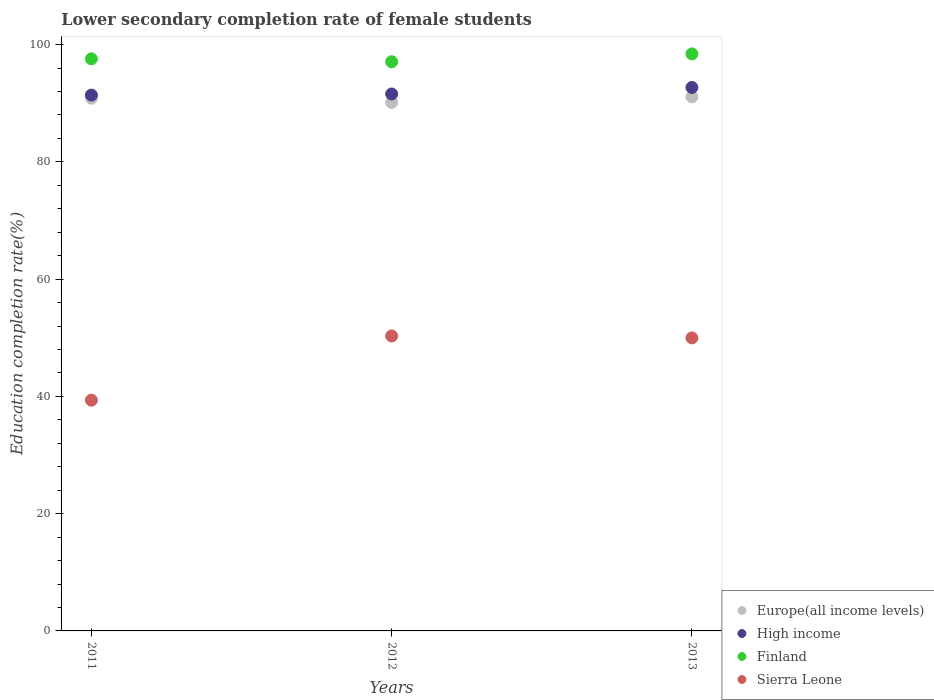What is the lower secondary completion rate of female students in Europe(all income levels) in 2012?
Give a very brief answer. 90.13. Across all years, what is the maximum lower secondary completion rate of female students in Sierra Leone?
Provide a short and direct response. 50.3. Across all years, what is the minimum lower secondary completion rate of female students in Europe(all income levels)?
Offer a very short reply. 90.13. What is the total lower secondary completion rate of female students in Finland in the graph?
Keep it short and to the point. 293.03. What is the difference between the lower secondary completion rate of female students in Europe(all income levels) in 2011 and that in 2012?
Keep it short and to the point. 0.72. What is the difference between the lower secondary completion rate of female students in Europe(all income levels) in 2011 and the lower secondary completion rate of female students in Finland in 2013?
Make the answer very short. -7.56. What is the average lower secondary completion rate of female students in Sierra Leone per year?
Your answer should be very brief. 46.54. In the year 2012, what is the difference between the lower secondary completion rate of female students in Europe(all income levels) and lower secondary completion rate of female students in High income?
Your response must be concise. -1.45. What is the ratio of the lower secondary completion rate of female students in Europe(all income levels) in 2012 to that in 2013?
Make the answer very short. 0.99. What is the difference between the highest and the second highest lower secondary completion rate of female students in Sierra Leone?
Offer a terse response. 0.33. What is the difference between the highest and the lowest lower secondary completion rate of female students in Sierra Leone?
Ensure brevity in your answer.  10.95. Is it the case that in every year, the sum of the lower secondary completion rate of female students in High income and lower secondary completion rate of female students in Sierra Leone  is greater than the sum of lower secondary completion rate of female students in Europe(all income levels) and lower secondary completion rate of female students in Finland?
Give a very brief answer. No. Is it the case that in every year, the sum of the lower secondary completion rate of female students in Europe(all income levels) and lower secondary completion rate of female students in Finland  is greater than the lower secondary completion rate of female students in Sierra Leone?
Your answer should be compact. Yes. Is the lower secondary completion rate of female students in Sierra Leone strictly less than the lower secondary completion rate of female students in High income over the years?
Ensure brevity in your answer.  Yes. How many dotlines are there?
Keep it short and to the point. 4. What is the difference between two consecutive major ticks on the Y-axis?
Your answer should be compact. 20. Are the values on the major ticks of Y-axis written in scientific E-notation?
Give a very brief answer. No. Does the graph contain any zero values?
Keep it short and to the point. No. Does the graph contain grids?
Make the answer very short. No. Where does the legend appear in the graph?
Your answer should be very brief. Bottom right. What is the title of the graph?
Keep it short and to the point. Lower secondary completion rate of female students. Does "Kenya" appear as one of the legend labels in the graph?
Ensure brevity in your answer.  No. What is the label or title of the Y-axis?
Your response must be concise. Education completion rate(%). What is the Education completion rate(%) of Europe(all income levels) in 2011?
Your response must be concise. 90.84. What is the Education completion rate(%) in High income in 2011?
Make the answer very short. 91.38. What is the Education completion rate(%) of Finland in 2011?
Provide a short and direct response. 97.56. What is the Education completion rate(%) of Sierra Leone in 2011?
Offer a terse response. 39.35. What is the Education completion rate(%) of Europe(all income levels) in 2012?
Provide a succinct answer. 90.13. What is the Education completion rate(%) in High income in 2012?
Give a very brief answer. 91.57. What is the Education completion rate(%) of Finland in 2012?
Your response must be concise. 97.06. What is the Education completion rate(%) of Sierra Leone in 2012?
Provide a short and direct response. 50.3. What is the Education completion rate(%) of Europe(all income levels) in 2013?
Keep it short and to the point. 91.08. What is the Education completion rate(%) of High income in 2013?
Provide a short and direct response. 92.68. What is the Education completion rate(%) of Finland in 2013?
Make the answer very short. 98.41. What is the Education completion rate(%) of Sierra Leone in 2013?
Provide a short and direct response. 49.97. Across all years, what is the maximum Education completion rate(%) in Europe(all income levels)?
Provide a succinct answer. 91.08. Across all years, what is the maximum Education completion rate(%) of High income?
Give a very brief answer. 92.68. Across all years, what is the maximum Education completion rate(%) of Finland?
Keep it short and to the point. 98.41. Across all years, what is the maximum Education completion rate(%) of Sierra Leone?
Ensure brevity in your answer.  50.3. Across all years, what is the minimum Education completion rate(%) in Europe(all income levels)?
Ensure brevity in your answer.  90.13. Across all years, what is the minimum Education completion rate(%) in High income?
Provide a succinct answer. 91.38. Across all years, what is the minimum Education completion rate(%) in Finland?
Your response must be concise. 97.06. Across all years, what is the minimum Education completion rate(%) in Sierra Leone?
Your answer should be very brief. 39.35. What is the total Education completion rate(%) of Europe(all income levels) in the graph?
Your response must be concise. 272.05. What is the total Education completion rate(%) of High income in the graph?
Offer a very short reply. 275.63. What is the total Education completion rate(%) of Finland in the graph?
Provide a short and direct response. 293.03. What is the total Education completion rate(%) of Sierra Leone in the graph?
Make the answer very short. 139.63. What is the difference between the Education completion rate(%) of Europe(all income levels) in 2011 and that in 2012?
Your answer should be compact. 0.72. What is the difference between the Education completion rate(%) of High income in 2011 and that in 2012?
Your answer should be very brief. -0.19. What is the difference between the Education completion rate(%) of Finland in 2011 and that in 2012?
Your answer should be compact. 0.5. What is the difference between the Education completion rate(%) in Sierra Leone in 2011 and that in 2012?
Your answer should be compact. -10.95. What is the difference between the Education completion rate(%) in Europe(all income levels) in 2011 and that in 2013?
Give a very brief answer. -0.24. What is the difference between the Education completion rate(%) in High income in 2011 and that in 2013?
Provide a succinct answer. -1.3. What is the difference between the Education completion rate(%) of Finland in 2011 and that in 2013?
Your answer should be very brief. -0.84. What is the difference between the Education completion rate(%) in Sierra Leone in 2011 and that in 2013?
Provide a short and direct response. -10.62. What is the difference between the Education completion rate(%) of Europe(all income levels) in 2012 and that in 2013?
Your answer should be very brief. -0.96. What is the difference between the Education completion rate(%) of High income in 2012 and that in 2013?
Make the answer very short. -1.11. What is the difference between the Education completion rate(%) in Finland in 2012 and that in 2013?
Keep it short and to the point. -1.34. What is the difference between the Education completion rate(%) in Sierra Leone in 2012 and that in 2013?
Make the answer very short. 0.33. What is the difference between the Education completion rate(%) in Europe(all income levels) in 2011 and the Education completion rate(%) in High income in 2012?
Your answer should be very brief. -0.73. What is the difference between the Education completion rate(%) of Europe(all income levels) in 2011 and the Education completion rate(%) of Finland in 2012?
Provide a short and direct response. -6.22. What is the difference between the Education completion rate(%) in Europe(all income levels) in 2011 and the Education completion rate(%) in Sierra Leone in 2012?
Your answer should be compact. 40.54. What is the difference between the Education completion rate(%) of High income in 2011 and the Education completion rate(%) of Finland in 2012?
Keep it short and to the point. -5.68. What is the difference between the Education completion rate(%) of High income in 2011 and the Education completion rate(%) of Sierra Leone in 2012?
Give a very brief answer. 41.08. What is the difference between the Education completion rate(%) in Finland in 2011 and the Education completion rate(%) in Sierra Leone in 2012?
Give a very brief answer. 47.26. What is the difference between the Education completion rate(%) in Europe(all income levels) in 2011 and the Education completion rate(%) in High income in 2013?
Provide a succinct answer. -1.84. What is the difference between the Education completion rate(%) of Europe(all income levels) in 2011 and the Education completion rate(%) of Finland in 2013?
Offer a very short reply. -7.56. What is the difference between the Education completion rate(%) in Europe(all income levels) in 2011 and the Education completion rate(%) in Sierra Leone in 2013?
Offer a very short reply. 40.87. What is the difference between the Education completion rate(%) in High income in 2011 and the Education completion rate(%) in Finland in 2013?
Your response must be concise. -7.02. What is the difference between the Education completion rate(%) of High income in 2011 and the Education completion rate(%) of Sierra Leone in 2013?
Make the answer very short. 41.41. What is the difference between the Education completion rate(%) in Finland in 2011 and the Education completion rate(%) in Sierra Leone in 2013?
Make the answer very short. 47.59. What is the difference between the Education completion rate(%) in Europe(all income levels) in 2012 and the Education completion rate(%) in High income in 2013?
Your answer should be very brief. -2.56. What is the difference between the Education completion rate(%) in Europe(all income levels) in 2012 and the Education completion rate(%) in Finland in 2013?
Your answer should be compact. -8.28. What is the difference between the Education completion rate(%) of Europe(all income levels) in 2012 and the Education completion rate(%) of Sierra Leone in 2013?
Your response must be concise. 40.15. What is the difference between the Education completion rate(%) of High income in 2012 and the Education completion rate(%) of Finland in 2013?
Give a very brief answer. -6.84. What is the difference between the Education completion rate(%) in High income in 2012 and the Education completion rate(%) in Sierra Leone in 2013?
Give a very brief answer. 41.6. What is the difference between the Education completion rate(%) of Finland in 2012 and the Education completion rate(%) of Sierra Leone in 2013?
Offer a very short reply. 47.09. What is the average Education completion rate(%) of Europe(all income levels) per year?
Give a very brief answer. 90.68. What is the average Education completion rate(%) of High income per year?
Ensure brevity in your answer.  91.88. What is the average Education completion rate(%) in Finland per year?
Ensure brevity in your answer.  97.68. What is the average Education completion rate(%) of Sierra Leone per year?
Your answer should be compact. 46.54. In the year 2011, what is the difference between the Education completion rate(%) in Europe(all income levels) and Education completion rate(%) in High income?
Keep it short and to the point. -0.54. In the year 2011, what is the difference between the Education completion rate(%) in Europe(all income levels) and Education completion rate(%) in Finland?
Provide a short and direct response. -6.72. In the year 2011, what is the difference between the Education completion rate(%) of Europe(all income levels) and Education completion rate(%) of Sierra Leone?
Provide a short and direct response. 51.49. In the year 2011, what is the difference between the Education completion rate(%) in High income and Education completion rate(%) in Finland?
Ensure brevity in your answer.  -6.18. In the year 2011, what is the difference between the Education completion rate(%) of High income and Education completion rate(%) of Sierra Leone?
Provide a succinct answer. 52.03. In the year 2011, what is the difference between the Education completion rate(%) in Finland and Education completion rate(%) in Sierra Leone?
Offer a terse response. 58.21. In the year 2012, what is the difference between the Education completion rate(%) in Europe(all income levels) and Education completion rate(%) in High income?
Offer a terse response. -1.45. In the year 2012, what is the difference between the Education completion rate(%) in Europe(all income levels) and Education completion rate(%) in Finland?
Keep it short and to the point. -6.94. In the year 2012, what is the difference between the Education completion rate(%) in Europe(all income levels) and Education completion rate(%) in Sierra Leone?
Your answer should be very brief. 39.82. In the year 2012, what is the difference between the Education completion rate(%) of High income and Education completion rate(%) of Finland?
Provide a succinct answer. -5.49. In the year 2012, what is the difference between the Education completion rate(%) in High income and Education completion rate(%) in Sierra Leone?
Provide a short and direct response. 41.27. In the year 2012, what is the difference between the Education completion rate(%) of Finland and Education completion rate(%) of Sierra Leone?
Keep it short and to the point. 46.76. In the year 2013, what is the difference between the Education completion rate(%) of Europe(all income levels) and Education completion rate(%) of High income?
Give a very brief answer. -1.6. In the year 2013, what is the difference between the Education completion rate(%) in Europe(all income levels) and Education completion rate(%) in Finland?
Your answer should be compact. -7.32. In the year 2013, what is the difference between the Education completion rate(%) in Europe(all income levels) and Education completion rate(%) in Sierra Leone?
Make the answer very short. 41.11. In the year 2013, what is the difference between the Education completion rate(%) of High income and Education completion rate(%) of Finland?
Offer a very short reply. -5.73. In the year 2013, what is the difference between the Education completion rate(%) of High income and Education completion rate(%) of Sierra Leone?
Your response must be concise. 42.71. In the year 2013, what is the difference between the Education completion rate(%) in Finland and Education completion rate(%) in Sierra Leone?
Your answer should be very brief. 48.44. What is the ratio of the Education completion rate(%) of Europe(all income levels) in 2011 to that in 2012?
Offer a very short reply. 1.01. What is the ratio of the Education completion rate(%) in Sierra Leone in 2011 to that in 2012?
Give a very brief answer. 0.78. What is the ratio of the Education completion rate(%) of Europe(all income levels) in 2011 to that in 2013?
Provide a short and direct response. 1. What is the ratio of the Education completion rate(%) of High income in 2011 to that in 2013?
Your response must be concise. 0.99. What is the ratio of the Education completion rate(%) in Finland in 2011 to that in 2013?
Your answer should be compact. 0.99. What is the ratio of the Education completion rate(%) of Sierra Leone in 2011 to that in 2013?
Ensure brevity in your answer.  0.79. What is the ratio of the Education completion rate(%) of Europe(all income levels) in 2012 to that in 2013?
Ensure brevity in your answer.  0.99. What is the ratio of the Education completion rate(%) of High income in 2012 to that in 2013?
Offer a very short reply. 0.99. What is the ratio of the Education completion rate(%) of Finland in 2012 to that in 2013?
Your answer should be very brief. 0.99. What is the ratio of the Education completion rate(%) of Sierra Leone in 2012 to that in 2013?
Ensure brevity in your answer.  1.01. What is the difference between the highest and the second highest Education completion rate(%) in Europe(all income levels)?
Offer a very short reply. 0.24. What is the difference between the highest and the second highest Education completion rate(%) of High income?
Offer a terse response. 1.11. What is the difference between the highest and the second highest Education completion rate(%) in Finland?
Your answer should be compact. 0.84. What is the difference between the highest and the second highest Education completion rate(%) of Sierra Leone?
Your answer should be very brief. 0.33. What is the difference between the highest and the lowest Education completion rate(%) of Europe(all income levels)?
Ensure brevity in your answer.  0.96. What is the difference between the highest and the lowest Education completion rate(%) in High income?
Your answer should be compact. 1.3. What is the difference between the highest and the lowest Education completion rate(%) in Finland?
Offer a very short reply. 1.34. What is the difference between the highest and the lowest Education completion rate(%) in Sierra Leone?
Ensure brevity in your answer.  10.95. 